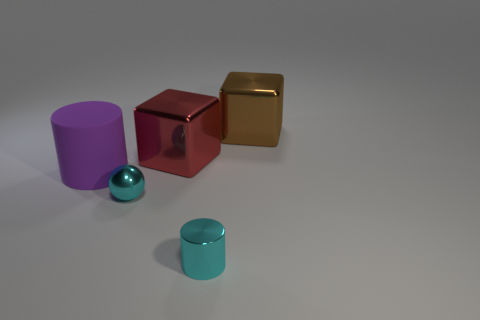What number of tiny objects have the same color as the tiny ball?
Your response must be concise. 1. The cylinder on the right side of the cylinder left of the cyan metal sphere that is behind the tiny shiny cylinder is what color?
Offer a very short reply. Cyan. Do the large object that is right of the cyan metal cylinder and the small cyan shiny object to the left of the cyan cylinder have the same shape?
Offer a very short reply. No. What number of tiny things are there?
Provide a short and direct response. 2. The object that is the same size as the ball is what color?
Ensure brevity in your answer.  Cyan. Are the cylinder that is in front of the purple cylinder and the thing on the left side of the small shiny sphere made of the same material?
Keep it short and to the point. No. What is the size of the cyan object that is to the left of the small thing in front of the shiny sphere?
Give a very brief answer. Small. There is a object that is on the left side of the metal ball; what is it made of?
Give a very brief answer. Rubber. How many objects are either big objects that are right of the purple rubber object or large things to the left of the red thing?
Your answer should be very brief. 3. There is another object that is the same shape as the large brown thing; what is it made of?
Provide a short and direct response. Metal. 